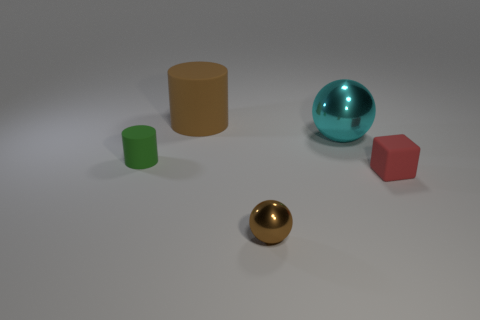What size is the green thing that is the same material as the red block?
Your answer should be compact. Small. There is a cylinder that is to the left of the big rubber object; how big is it?
Offer a very short reply. Small. What number of cyan metallic things are the same size as the brown matte object?
Give a very brief answer. 1. The metal thing that is the same color as the large cylinder is what size?
Provide a short and direct response. Small. Are there any big cylinders that have the same color as the large matte thing?
Ensure brevity in your answer.  No. There is a rubber cylinder that is the same size as the matte cube; what is its color?
Your answer should be compact. Green. Does the big cylinder have the same color as the metal object that is behind the tiny red thing?
Offer a terse response. No. The small metal thing has what color?
Keep it short and to the point. Brown. What is the material of the sphere that is in front of the green thing?
Keep it short and to the point. Metal. What is the size of the other object that is the same shape as the green thing?
Make the answer very short. Large. 